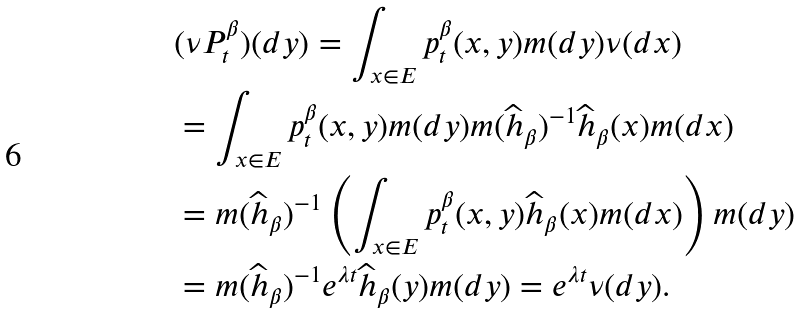Convert formula to latex. <formula><loc_0><loc_0><loc_500><loc_500>& ( \nu P _ { t } ^ { \beta } ) ( d y ) = \int _ { x \in E } p _ { t } ^ { \beta } ( x , y ) m ( d y ) \nu ( d x ) \\ & = \int _ { x \in E } p _ { t } ^ { \beta } ( x , y ) m ( d y ) m ( \widehat { h } _ { \beta } ) ^ { - 1 } \widehat { h } _ { \beta } ( x ) m ( d x ) \\ & = m ( \widehat { h } _ { \beta } ) ^ { - 1 } \left ( \int _ { x \in E } p _ { t } ^ { \beta } ( x , y ) \widehat { h } _ { \beta } ( x ) m ( d x ) \right ) m ( d y ) \\ & = m ( \widehat { h } _ { \beta } ) ^ { - 1 } e ^ { \lambda t } \widehat { h } _ { \beta } ( y ) m ( d y ) = e ^ { \lambda t } \nu ( d y ) .</formula> 